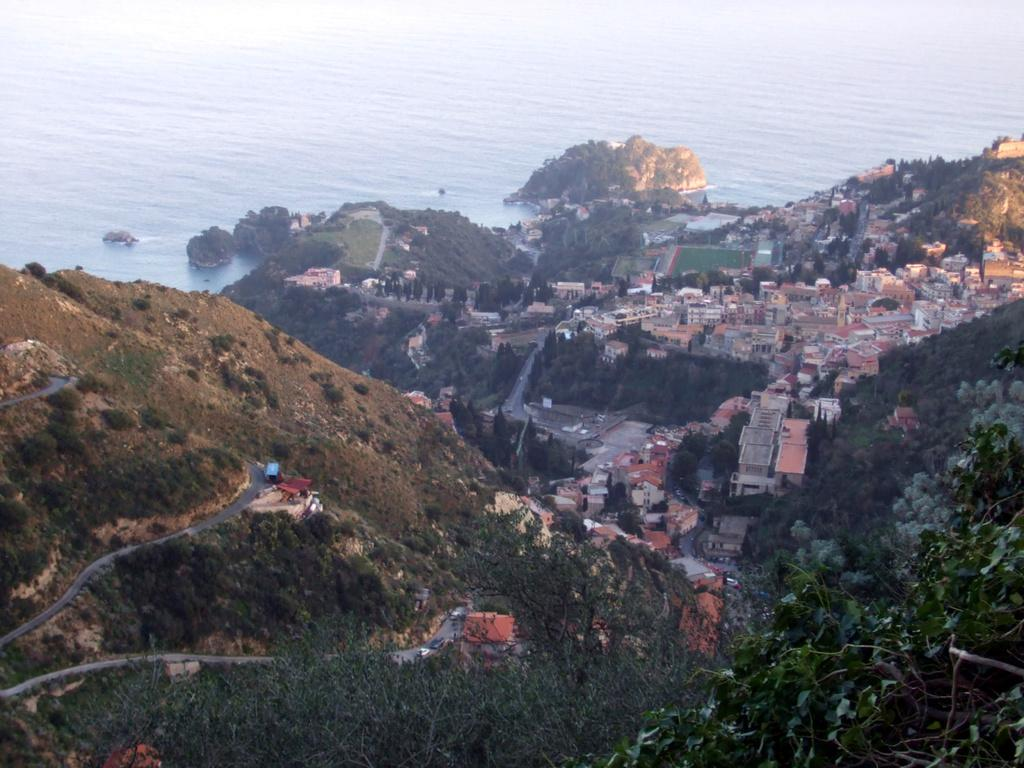What type of structures can be seen in the image? There is a group of buildings in the image. What natural elements are present in the image? There are trees and hills visible in the image. What man-made features can be seen in the image? There are pathways in the image. What type of landscape feature is present in the image? There is a large water body in the image. Can you tell me how many robins are perched on the trees in the image? There are no robins present in the image; it features trees, buildings, pathways, hills, and a large water body. What type of respect is being shown by the liquid in the image? There is no liquid present in the image, and therefore no such interaction can be observed. 